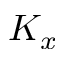Convert formula to latex. <formula><loc_0><loc_0><loc_500><loc_500>K _ { x }</formula> 